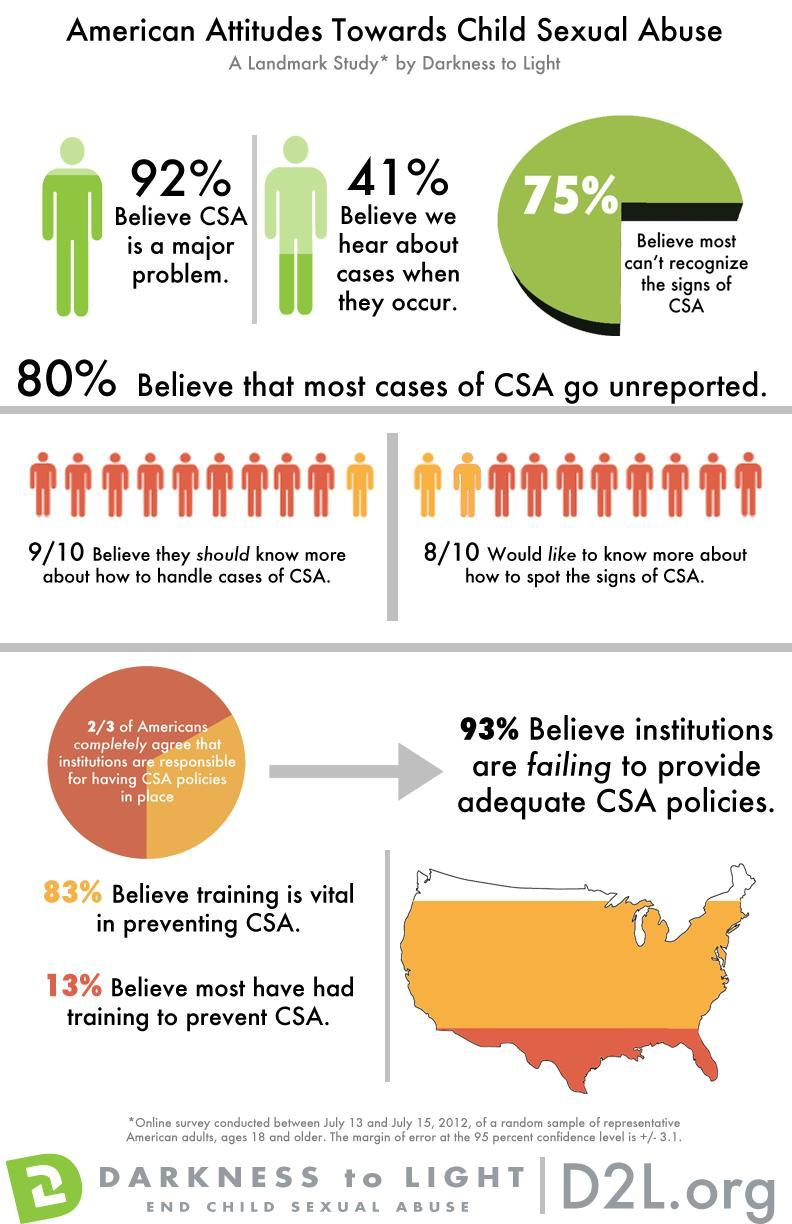What percent of people believe that Child Sexual Abuse is a major issue?
Answer the question with a short phrase. 92% 